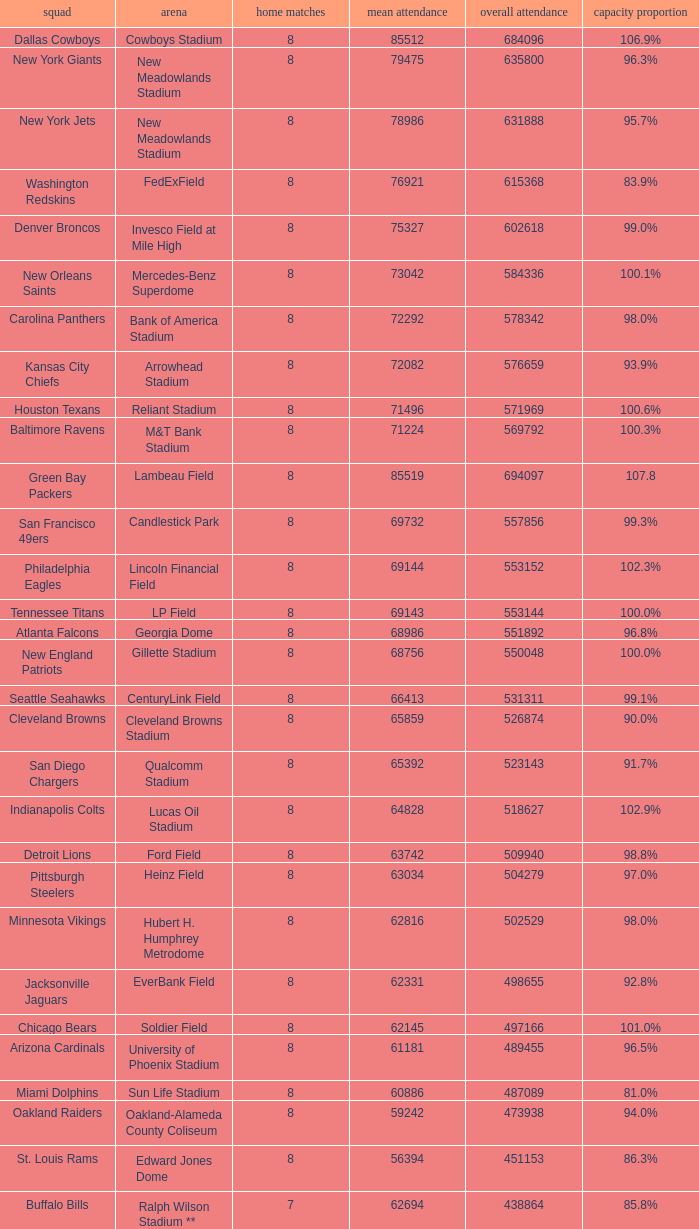How many home games are listed when the average attendance is 79475? 1.0. 